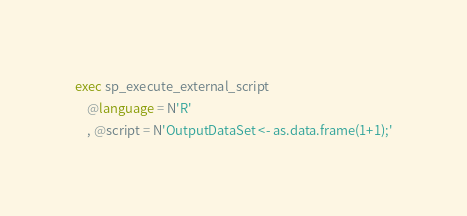<code> <loc_0><loc_0><loc_500><loc_500><_SQL_>exec sp_execute_external_script
    @language = N'R'
    , @script = N'OutputDataSet <- as.data.frame(1+1);'</code> 